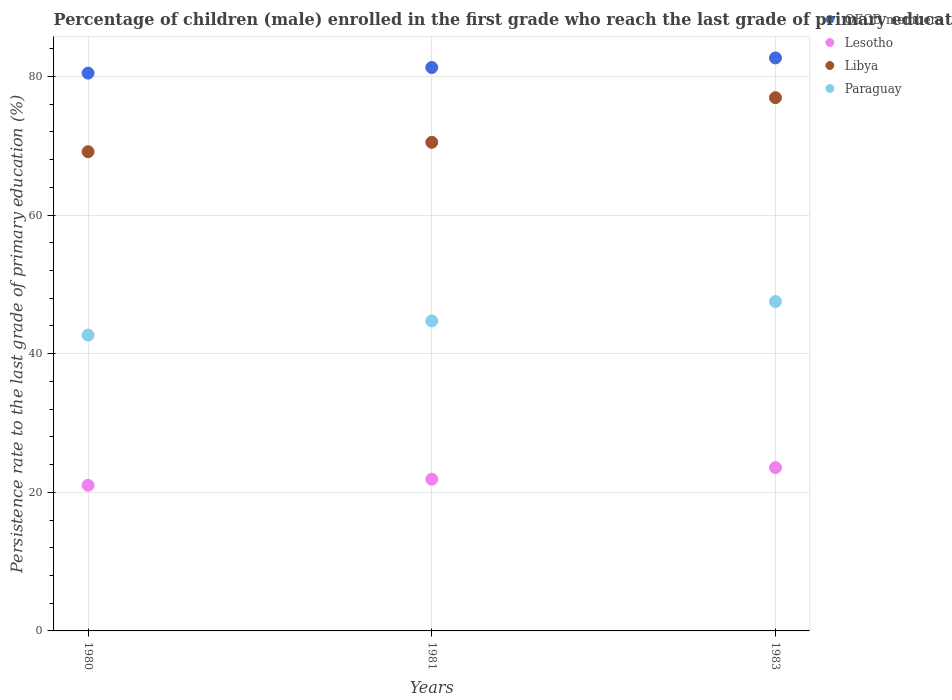Is the number of dotlines equal to the number of legend labels?
Make the answer very short. Yes. What is the persistence rate of children in OECD members in 1980?
Your answer should be compact. 80.48. Across all years, what is the maximum persistence rate of children in Lesotho?
Offer a very short reply. 23.56. Across all years, what is the minimum persistence rate of children in OECD members?
Your answer should be compact. 80.48. In which year was the persistence rate of children in OECD members maximum?
Your answer should be very brief. 1983. In which year was the persistence rate of children in Lesotho minimum?
Your answer should be compact. 1980. What is the total persistence rate of children in Lesotho in the graph?
Offer a terse response. 66.47. What is the difference between the persistence rate of children in Lesotho in 1980 and that in 1983?
Your answer should be compact. -2.55. What is the difference between the persistence rate of children in Paraguay in 1983 and the persistence rate of children in OECD members in 1981?
Your answer should be compact. -33.77. What is the average persistence rate of children in Libya per year?
Ensure brevity in your answer.  72.19. In the year 1981, what is the difference between the persistence rate of children in OECD members and persistence rate of children in Libya?
Your answer should be very brief. 10.79. In how many years, is the persistence rate of children in Lesotho greater than 76 %?
Ensure brevity in your answer.  0. What is the ratio of the persistence rate of children in Lesotho in 1980 to that in 1983?
Offer a very short reply. 0.89. Is the difference between the persistence rate of children in OECD members in 1980 and 1983 greater than the difference between the persistence rate of children in Libya in 1980 and 1983?
Give a very brief answer. Yes. What is the difference between the highest and the second highest persistence rate of children in Lesotho?
Make the answer very short. 1.67. What is the difference between the highest and the lowest persistence rate of children in Libya?
Provide a succinct answer. 7.8. In how many years, is the persistence rate of children in Paraguay greater than the average persistence rate of children in Paraguay taken over all years?
Make the answer very short. 1. Does the persistence rate of children in OECD members monotonically increase over the years?
Give a very brief answer. Yes. Is the persistence rate of children in OECD members strictly greater than the persistence rate of children in Lesotho over the years?
Offer a very short reply. Yes. How many dotlines are there?
Ensure brevity in your answer.  4. What is the difference between two consecutive major ticks on the Y-axis?
Provide a short and direct response. 20. Does the graph contain grids?
Provide a succinct answer. Yes. How are the legend labels stacked?
Keep it short and to the point. Vertical. What is the title of the graph?
Offer a very short reply. Percentage of children (male) enrolled in the first grade who reach the last grade of primary education. Does "Turkey" appear as one of the legend labels in the graph?
Your answer should be very brief. No. What is the label or title of the X-axis?
Make the answer very short. Years. What is the label or title of the Y-axis?
Give a very brief answer. Persistence rate to the last grade of primary education (%). What is the Persistence rate to the last grade of primary education (%) in OECD members in 1980?
Provide a short and direct response. 80.48. What is the Persistence rate to the last grade of primary education (%) of Lesotho in 1980?
Offer a very short reply. 21.01. What is the Persistence rate to the last grade of primary education (%) in Libya in 1980?
Provide a succinct answer. 69.14. What is the Persistence rate to the last grade of primary education (%) of Paraguay in 1980?
Provide a succinct answer. 42.68. What is the Persistence rate to the last grade of primary education (%) in OECD members in 1981?
Your answer should be very brief. 81.29. What is the Persistence rate to the last grade of primary education (%) in Lesotho in 1981?
Your answer should be very brief. 21.89. What is the Persistence rate to the last grade of primary education (%) of Libya in 1981?
Give a very brief answer. 70.5. What is the Persistence rate to the last grade of primary education (%) of Paraguay in 1981?
Your response must be concise. 44.73. What is the Persistence rate to the last grade of primary education (%) in OECD members in 1983?
Give a very brief answer. 82.67. What is the Persistence rate to the last grade of primary education (%) of Lesotho in 1983?
Provide a succinct answer. 23.56. What is the Persistence rate to the last grade of primary education (%) in Libya in 1983?
Provide a succinct answer. 76.94. What is the Persistence rate to the last grade of primary education (%) in Paraguay in 1983?
Keep it short and to the point. 47.53. Across all years, what is the maximum Persistence rate to the last grade of primary education (%) of OECD members?
Your response must be concise. 82.67. Across all years, what is the maximum Persistence rate to the last grade of primary education (%) of Lesotho?
Offer a terse response. 23.56. Across all years, what is the maximum Persistence rate to the last grade of primary education (%) of Libya?
Give a very brief answer. 76.94. Across all years, what is the maximum Persistence rate to the last grade of primary education (%) of Paraguay?
Keep it short and to the point. 47.53. Across all years, what is the minimum Persistence rate to the last grade of primary education (%) of OECD members?
Keep it short and to the point. 80.48. Across all years, what is the minimum Persistence rate to the last grade of primary education (%) in Lesotho?
Your response must be concise. 21.01. Across all years, what is the minimum Persistence rate to the last grade of primary education (%) of Libya?
Keep it short and to the point. 69.14. Across all years, what is the minimum Persistence rate to the last grade of primary education (%) of Paraguay?
Keep it short and to the point. 42.68. What is the total Persistence rate to the last grade of primary education (%) of OECD members in the graph?
Offer a very short reply. 244.45. What is the total Persistence rate to the last grade of primary education (%) in Lesotho in the graph?
Provide a short and direct response. 66.47. What is the total Persistence rate to the last grade of primary education (%) in Libya in the graph?
Make the answer very short. 216.58. What is the total Persistence rate to the last grade of primary education (%) of Paraguay in the graph?
Your answer should be compact. 134.94. What is the difference between the Persistence rate to the last grade of primary education (%) of OECD members in 1980 and that in 1981?
Give a very brief answer. -0.81. What is the difference between the Persistence rate to the last grade of primary education (%) of Lesotho in 1980 and that in 1981?
Offer a very short reply. -0.88. What is the difference between the Persistence rate to the last grade of primary education (%) of Libya in 1980 and that in 1981?
Your answer should be compact. -1.36. What is the difference between the Persistence rate to the last grade of primary education (%) of Paraguay in 1980 and that in 1981?
Your answer should be compact. -2.04. What is the difference between the Persistence rate to the last grade of primary education (%) in OECD members in 1980 and that in 1983?
Keep it short and to the point. -2.19. What is the difference between the Persistence rate to the last grade of primary education (%) in Lesotho in 1980 and that in 1983?
Give a very brief answer. -2.55. What is the difference between the Persistence rate to the last grade of primary education (%) in Libya in 1980 and that in 1983?
Give a very brief answer. -7.8. What is the difference between the Persistence rate to the last grade of primary education (%) of Paraguay in 1980 and that in 1983?
Offer a very short reply. -4.84. What is the difference between the Persistence rate to the last grade of primary education (%) of OECD members in 1981 and that in 1983?
Your answer should be compact. -1.38. What is the difference between the Persistence rate to the last grade of primary education (%) in Lesotho in 1981 and that in 1983?
Offer a very short reply. -1.67. What is the difference between the Persistence rate to the last grade of primary education (%) in Libya in 1981 and that in 1983?
Make the answer very short. -6.44. What is the difference between the Persistence rate to the last grade of primary education (%) of Paraguay in 1981 and that in 1983?
Make the answer very short. -2.8. What is the difference between the Persistence rate to the last grade of primary education (%) in OECD members in 1980 and the Persistence rate to the last grade of primary education (%) in Lesotho in 1981?
Give a very brief answer. 58.59. What is the difference between the Persistence rate to the last grade of primary education (%) in OECD members in 1980 and the Persistence rate to the last grade of primary education (%) in Libya in 1981?
Ensure brevity in your answer.  9.98. What is the difference between the Persistence rate to the last grade of primary education (%) of OECD members in 1980 and the Persistence rate to the last grade of primary education (%) of Paraguay in 1981?
Provide a succinct answer. 35.75. What is the difference between the Persistence rate to the last grade of primary education (%) of Lesotho in 1980 and the Persistence rate to the last grade of primary education (%) of Libya in 1981?
Your answer should be very brief. -49.49. What is the difference between the Persistence rate to the last grade of primary education (%) of Lesotho in 1980 and the Persistence rate to the last grade of primary education (%) of Paraguay in 1981?
Your answer should be compact. -23.72. What is the difference between the Persistence rate to the last grade of primary education (%) in Libya in 1980 and the Persistence rate to the last grade of primary education (%) in Paraguay in 1981?
Your answer should be compact. 24.42. What is the difference between the Persistence rate to the last grade of primary education (%) of OECD members in 1980 and the Persistence rate to the last grade of primary education (%) of Lesotho in 1983?
Make the answer very short. 56.92. What is the difference between the Persistence rate to the last grade of primary education (%) of OECD members in 1980 and the Persistence rate to the last grade of primary education (%) of Libya in 1983?
Make the answer very short. 3.54. What is the difference between the Persistence rate to the last grade of primary education (%) of OECD members in 1980 and the Persistence rate to the last grade of primary education (%) of Paraguay in 1983?
Provide a short and direct response. 32.96. What is the difference between the Persistence rate to the last grade of primary education (%) in Lesotho in 1980 and the Persistence rate to the last grade of primary education (%) in Libya in 1983?
Your response must be concise. -55.93. What is the difference between the Persistence rate to the last grade of primary education (%) in Lesotho in 1980 and the Persistence rate to the last grade of primary education (%) in Paraguay in 1983?
Give a very brief answer. -26.51. What is the difference between the Persistence rate to the last grade of primary education (%) in Libya in 1980 and the Persistence rate to the last grade of primary education (%) in Paraguay in 1983?
Give a very brief answer. 21.62. What is the difference between the Persistence rate to the last grade of primary education (%) of OECD members in 1981 and the Persistence rate to the last grade of primary education (%) of Lesotho in 1983?
Offer a very short reply. 57.73. What is the difference between the Persistence rate to the last grade of primary education (%) of OECD members in 1981 and the Persistence rate to the last grade of primary education (%) of Libya in 1983?
Offer a very short reply. 4.35. What is the difference between the Persistence rate to the last grade of primary education (%) in OECD members in 1981 and the Persistence rate to the last grade of primary education (%) in Paraguay in 1983?
Your answer should be very brief. 33.77. What is the difference between the Persistence rate to the last grade of primary education (%) in Lesotho in 1981 and the Persistence rate to the last grade of primary education (%) in Libya in 1983?
Offer a terse response. -55.05. What is the difference between the Persistence rate to the last grade of primary education (%) of Lesotho in 1981 and the Persistence rate to the last grade of primary education (%) of Paraguay in 1983?
Ensure brevity in your answer.  -25.63. What is the difference between the Persistence rate to the last grade of primary education (%) in Libya in 1981 and the Persistence rate to the last grade of primary education (%) in Paraguay in 1983?
Provide a succinct answer. 22.98. What is the average Persistence rate to the last grade of primary education (%) of OECD members per year?
Give a very brief answer. 81.48. What is the average Persistence rate to the last grade of primary education (%) in Lesotho per year?
Give a very brief answer. 22.16. What is the average Persistence rate to the last grade of primary education (%) in Libya per year?
Give a very brief answer. 72.19. What is the average Persistence rate to the last grade of primary education (%) of Paraguay per year?
Provide a short and direct response. 44.98. In the year 1980, what is the difference between the Persistence rate to the last grade of primary education (%) of OECD members and Persistence rate to the last grade of primary education (%) of Lesotho?
Your response must be concise. 59.47. In the year 1980, what is the difference between the Persistence rate to the last grade of primary education (%) in OECD members and Persistence rate to the last grade of primary education (%) in Libya?
Offer a very short reply. 11.34. In the year 1980, what is the difference between the Persistence rate to the last grade of primary education (%) of OECD members and Persistence rate to the last grade of primary education (%) of Paraguay?
Keep it short and to the point. 37.8. In the year 1980, what is the difference between the Persistence rate to the last grade of primary education (%) of Lesotho and Persistence rate to the last grade of primary education (%) of Libya?
Offer a very short reply. -48.13. In the year 1980, what is the difference between the Persistence rate to the last grade of primary education (%) of Lesotho and Persistence rate to the last grade of primary education (%) of Paraguay?
Provide a succinct answer. -21.67. In the year 1980, what is the difference between the Persistence rate to the last grade of primary education (%) of Libya and Persistence rate to the last grade of primary education (%) of Paraguay?
Provide a short and direct response. 26.46. In the year 1981, what is the difference between the Persistence rate to the last grade of primary education (%) in OECD members and Persistence rate to the last grade of primary education (%) in Lesotho?
Offer a terse response. 59.4. In the year 1981, what is the difference between the Persistence rate to the last grade of primary education (%) of OECD members and Persistence rate to the last grade of primary education (%) of Libya?
Ensure brevity in your answer.  10.79. In the year 1981, what is the difference between the Persistence rate to the last grade of primary education (%) of OECD members and Persistence rate to the last grade of primary education (%) of Paraguay?
Offer a very short reply. 36.57. In the year 1981, what is the difference between the Persistence rate to the last grade of primary education (%) of Lesotho and Persistence rate to the last grade of primary education (%) of Libya?
Your response must be concise. -48.61. In the year 1981, what is the difference between the Persistence rate to the last grade of primary education (%) in Lesotho and Persistence rate to the last grade of primary education (%) in Paraguay?
Ensure brevity in your answer.  -22.84. In the year 1981, what is the difference between the Persistence rate to the last grade of primary education (%) in Libya and Persistence rate to the last grade of primary education (%) in Paraguay?
Provide a succinct answer. 25.77. In the year 1983, what is the difference between the Persistence rate to the last grade of primary education (%) in OECD members and Persistence rate to the last grade of primary education (%) in Lesotho?
Offer a very short reply. 59.11. In the year 1983, what is the difference between the Persistence rate to the last grade of primary education (%) in OECD members and Persistence rate to the last grade of primary education (%) in Libya?
Keep it short and to the point. 5.73. In the year 1983, what is the difference between the Persistence rate to the last grade of primary education (%) in OECD members and Persistence rate to the last grade of primary education (%) in Paraguay?
Your answer should be very brief. 35.15. In the year 1983, what is the difference between the Persistence rate to the last grade of primary education (%) in Lesotho and Persistence rate to the last grade of primary education (%) in Libya?
Offer a terse response. -53.38. In the year 1983, what is the difference between the Persistence rate to the last grade of primary education (%) of Lesotho and Persistence rate to the last grade of primary education (%) of Paraguay?
Provide a short and direct response. -23.96. In the year 1983, what is the difference between the Persistence rate to the last grade of primary education (%) in Libya and Persistence rate to the last grade of primary education (%) in Paraguay?
Provide a short and direct response. 29.42. What is the ratio of the Persistence rate to the last grade of primary education (%) in Lesotho in 1980 to that in 1981?
Offer a very short reply. 0.96. What is the ratio of the Persistence rate to the last grade of primary education (%) of Libya in 1980 to that in 1981?
Your response must be concise. 0.98. What is the ratio of the Persistence rate to the last grade of primary education (%) of Paraguay in 1980 to that in 1981?
Provide a short and direct response. 0.95. What is the ratio of the Persistence rate to the last grade of primary education (%) of OECD members in 1980 to that in 1983?
Provide a short and direct response. 0.97. What is the ratio of the Persistence rate to the last grade of primary education (%) of Lesotho in 1980 to that in 1983?
Offer a very short reply. 0.89. What is the ratio of the Persistence rate to the last grade of primary education (%) in Libya in 1980 to that in 1983?
Your answer should be very brief. 0.9. What is the ratio of the Persistence rate to the last grade of primary education (%) in Paraguay in 1980 to that in 1983?
Give a very brief answer. 0.9. What is the ratio of the Persistence rate to the last grade of primary education (%) of OECD members in 1981 to that in 1983?
Make the answer very short. 0.98. What is the ratio of the Persistence rate to the last grade of primary education (%) of Lesotho in 1981 to that in 1983?
Your answer should be very brief. 0.93. What is the ratio of the Persistence rate to the last grade of primary education (%) of Libya in 1981 to that in 1983?
Your answer should be compact. 0.92. What is the ratio of the Persistence rate to the last grade of primary education (%) in Paraguay in 1981 to that in 1983?
Offer a very short reply. 0.94. What is the difference between the highest and the second highest Persistence rate to the last grade of primary education (%) in OECD members?
Make the answer very short. 1.38. What is the difference between the highest and the second highest Persistence rate to the last grade of primary education (%) of Lesotho?
Provide a short and direct response. 1.67. What is the difference between the highest and the second highest Persistence rate to the last grade of primary education (%) in Libya?
Provide a short and direct response. 6.44. What is the difference between the highest and the second highest Persistence rate to the last grade of primary education (%) of Paraguay?
Your answer should be very brief. 2.8. What is the difference between the highest and the lowest Persistence rate to the last grade of primary education (%) in OECD members?
Make the answer very short. 2.19. What is the difference between the highest and the lowest Persistence rate to the last grade of primary education (%) in Lesotho?
Provide a succinct answer. 2.55. What is the difference between the highest and the lowest Persistence rate to the last grade of primary education (%) of Libya?
Offer a terse response. 7.8. What is the difference between the highest and the lowest Persistence rate to the last grade of primary education (%) in Paraguay?
Provide a short and direct response. 4.84. 